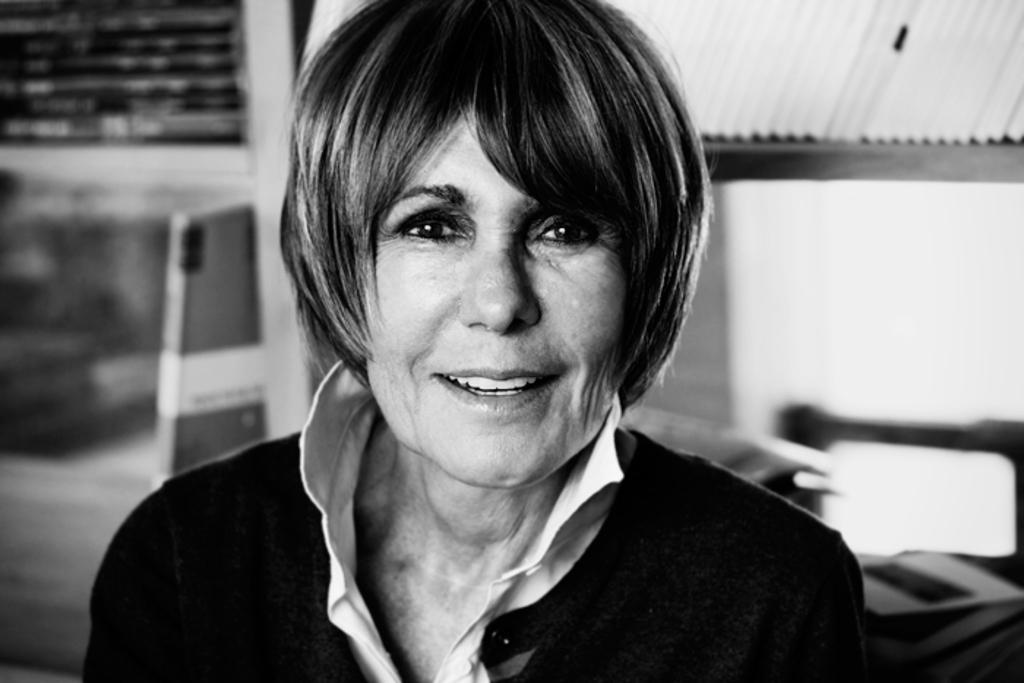Who or what is present in the image? There is a person in the image. What is the person doing or expressing? The person is smiling. What can be seen behind the person? There are objects visible in the background. What color scheme is used in the image? The image is in black and white. What type of cub is visible in the image? There is no cub present in the image. What is the chance of winning a prize in the image? There is no mention of winning a prize in the image. 